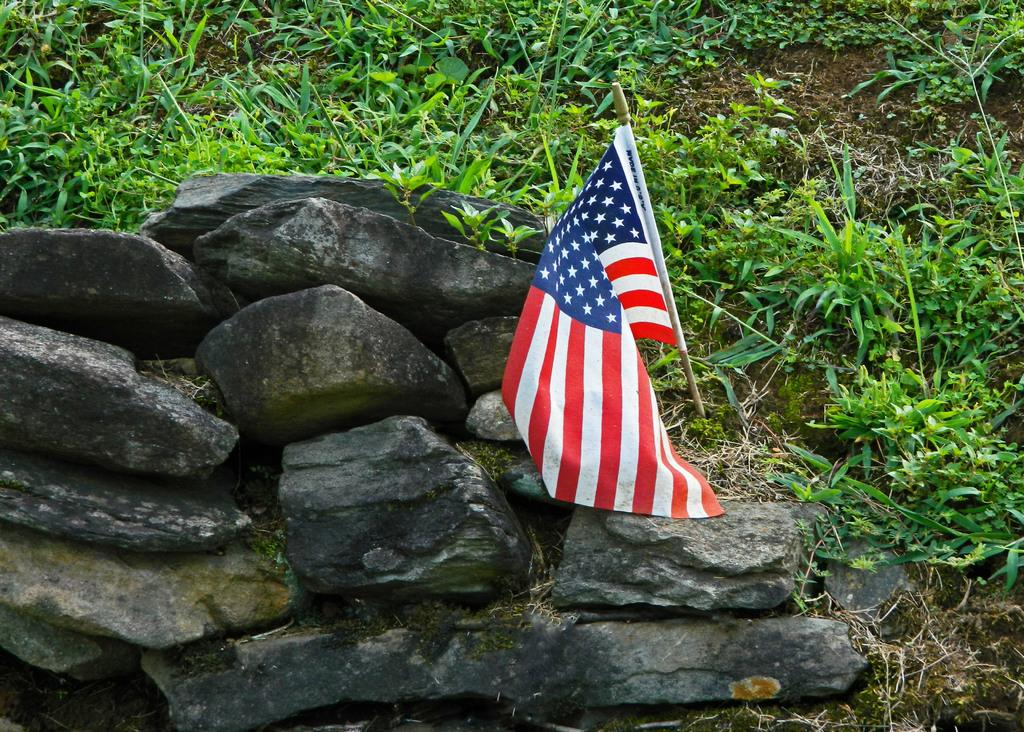What type of natural elements can be seen in the image? There are rocks in the image. What man-made object is visible in the front of the image? There is a flag in the front of the image. What type of vegetation is present in the background of the image? There are plants in the background of the image. Can you tell me how many beads are strung on the flag in the image? There are no beads present on the flag in the image. What type of snail can be seen crawling on the rocks in the image? There are no snails visible in the image; it only features rocks, a flag, and plants. 